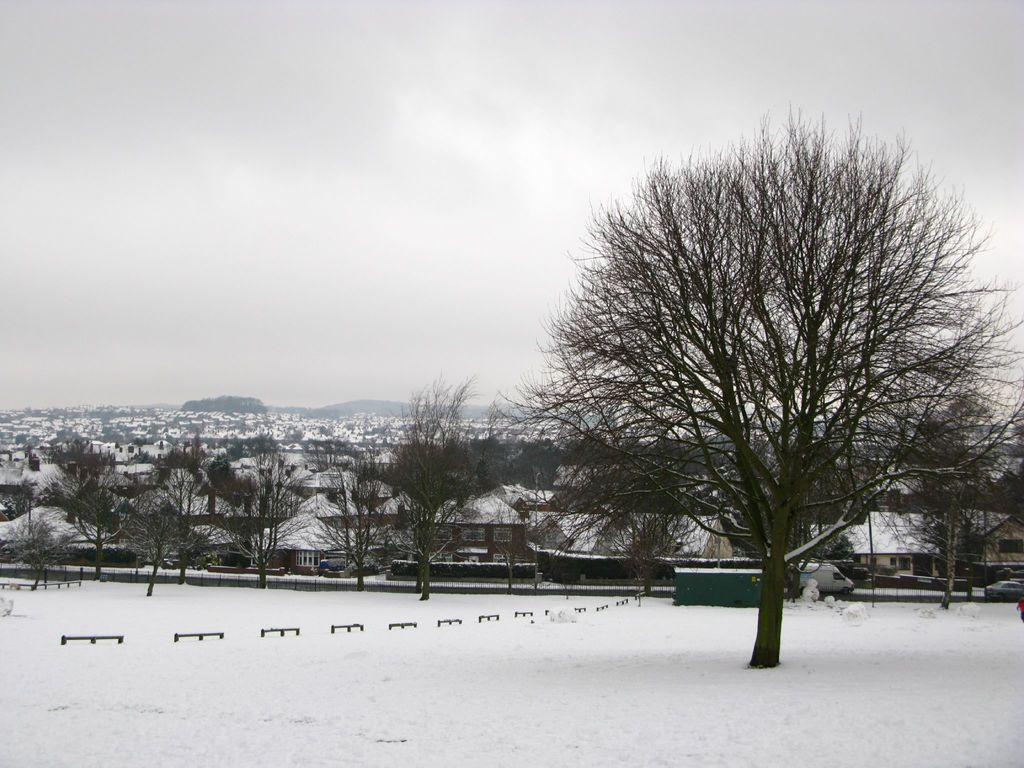What structures are located in the center of the image? There are houses in the center of the image. What else can be seen in the center of the image besides houses? There are trees, a truck, and a car in the center of the image. What is visible at the top of the image? The sky is visible at the top of the image. What type of weather is depicted in the image? Snow is present at the bottom of the image, indicating a snowy scene. What type of dress is hanging on the tree in the image? There is no dress present in the image; it features houses, trees, a truck, and a car in a snowy scene. What range of stockings can be seen on the houses in the image? There are no stockings present on the houses in the image. 